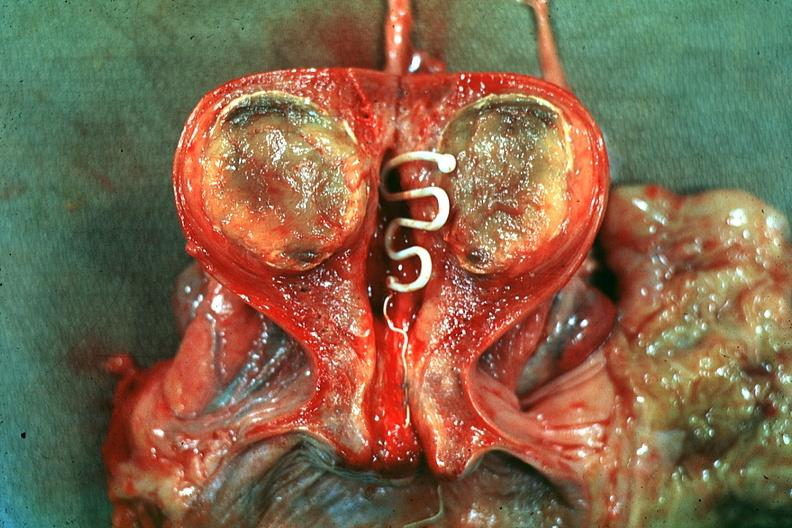s autopsy present?
Answer the question using a single word or phrase. No 